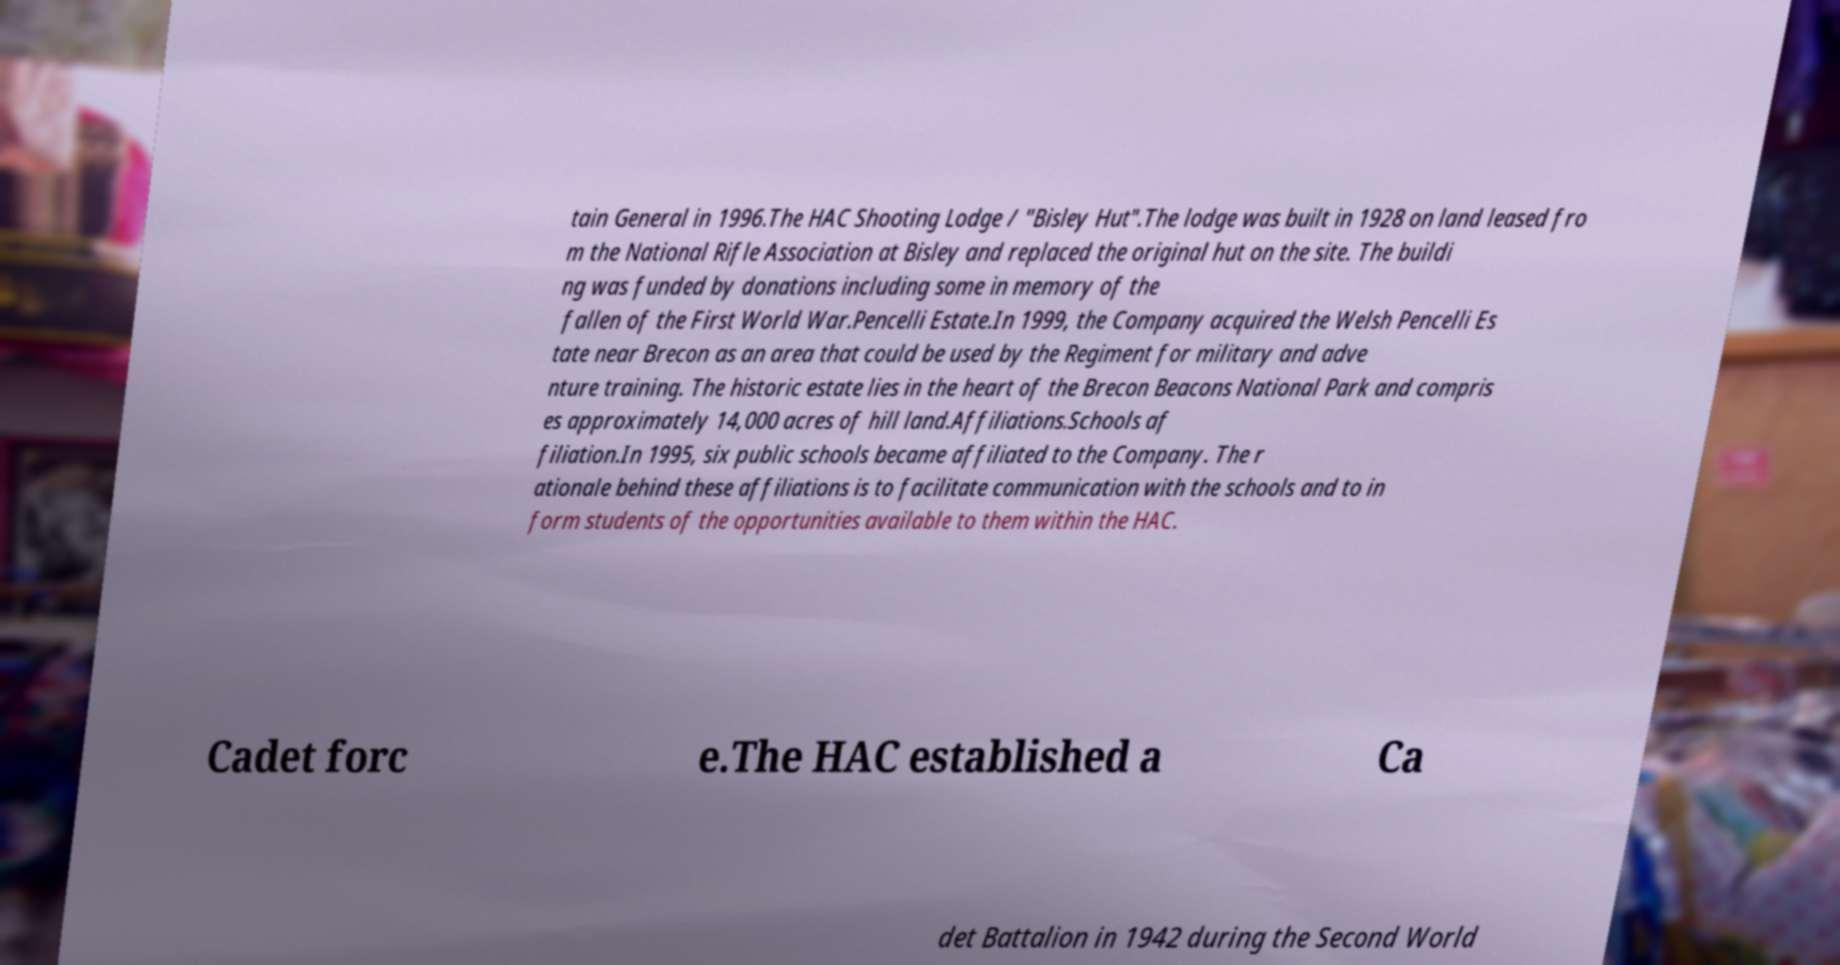Please read and relay the text visible in this image. What does it say? tain General in 1996.The HAC Shooting Lodge / "Bisley Hut".The lodge was built in 1928 on land leased fro m the National Rifle Association at Bisley and replaced the original hut on the site. The buildi ng was funded by donations including some in memory of the fallen of the First World War.Pencelli Estate.In 1999, the Company acquired the Welsh Pencelli Es tate near Brecon as an area that could be used by the Regiment for military and adve nture training. The historic estate lies in the heart of the Brecon Beacons National Park and compris es approximately 14,000 acres of hill land.Affiliations.Schools af filiation.In 1995, six public schools became affiliated to the Company. The r ationale behind these affiliations is to facilitate communication with the schools and to in form students of the opportunities available to them within the HAC. Cadet forc e.The HAC established a Ca det Battalion in 1942 during the Second World 